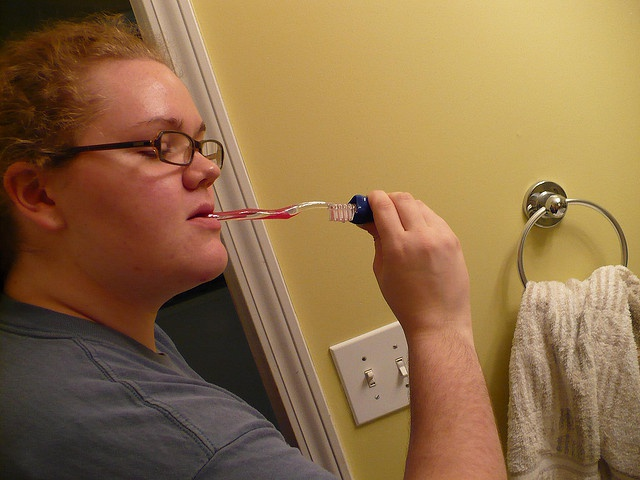Describe the objects in this image and their specific colors. I can see people in black, maroon, salmon, and gray tones and toothbrush in black, brown, and tan tones in this image. 